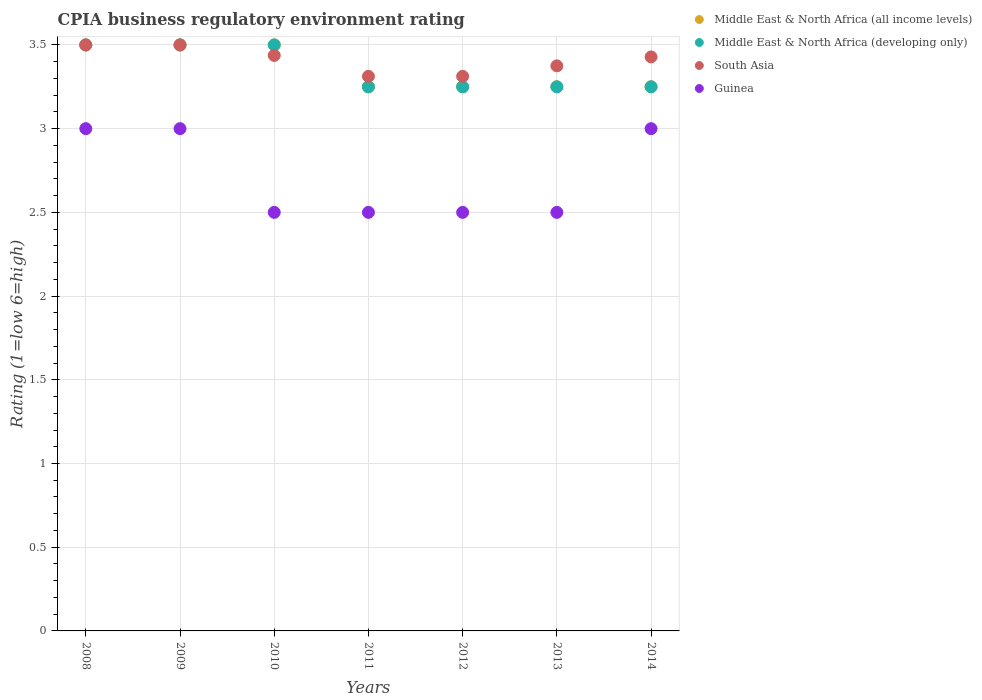How many different coloured dotlines are there?
Your answer should be compact. 4. What is the CPIA rating in Guinea in 2010?
Your answer should be compact. 2.5. Across all years, what is the minimum CPIA rating in South Asia?
Offer a very short reply. 3.31. In which year was the CPIA rating in Middle East & North Africa (all income levels) maximum?
Ensure brevity in your answer.  2008. In which year was the CPIA rating in Guinea minimum?
Offer a very short reply. 2010. What is the total CPIA rating in Middle East & North Africa (developing only) in the graph?
Your answer should be very brief. 23.5. What is the difference between the CPIA rating in Guinea in 2010 and that in 2014?
Your response must be concise. -0.5. What is the average CPIA rating in Guinea per year?
Your response must be concise. 2.71. Is the CPIA rating in Middle East & North Africa (developing only) in 2011 less than that in 2012?
Provide a short and direct response. No. Is the difference between the CPIA rating in Middle East & North Africa (developing only) in 2008 and 2009 greater than the difference between the CPIA rating in South Asia in 2008 and 2009?
Provide a succinct answer. No. What is the difference between the highest and the lowest CPIA rating in South Asia?
Your answer should be compact. 0.19. Is the CPIA rating in South Asia strictly greater than the CPIA rating in Middle East & North Africa (all income levels) over the years?
Ensure brevity in your answer.  No. Is the CPIA rating in Middle East & North Africa (all income levels) strictly less than the CPIA rating in Middle East & North Africa (developing only) over the years?
Ensure brevity in your answer.  No. How many years are there in the graph?
Provide a succinct answer. 7. What is the difference between two consecutive major ticks on the Y-axis?
Make the answer very short. 0.5. Are the values on the major ticks of Y-axis written in scientific E-notation?
Offer a very short reply. No. Where does the legend appear in the graph?
Provide a succinct answer. Top right. How are the legend labels stacked?
Your response must be concise. Vertical. What is the title of the graph?
Give a very brief answer. CPIA business regulatory environment rating. Does "South Sudan" appear as one of the legend labels in the graph?
Offer a very short reply. No. What is the label or title of the X-axis?
Your response must be concise. Years. What is the label or title of the Y-axis?
Ensure brevity in your answer.  Rating (1=low 6=high). What is the Rating (1=low 6=high) of Middle East & North Africa (all income levels) in 2008?
Offer a terse response. 3.5. What is the Rating (1=low 6=high) of Guinea in 2008?
Offer a very short reply. 3. What is the Rating (1=low 6=high) in Guinea in 2009?
Provide a succinct answer. 3. What is the Rating (1=low 6=high) in Middle East & North Africa (developing only) in 2010?
Keep it short and to the point. 3.5. What is the Rating (1=low 6=high) of South Asia in 2010?
Ensure brevity in your answer.  3.44. What is the Rating (1=low 6=high) of Middle East & North Africa (developing only) in 2011?
Provide a short and direct response. 3.25. What is the Rating (1=low 6=high) in South Asia in 2011?
Make the answer very short. 3.31. What is the Rating (1=low 6=high) of Guinea in 2011?
Offer a terse response. 2.5. What is the Rating (1=low 6=high) of Middle East & North Africa (developing only) in 2012?
Keep it short and to the point. 3.25. What is the Rating (1=low 6=high) of South Asia in 2012?
Offer a very short reply. 3.31. What is the Rating (1=low 6=high) of Guinea in 2012?
Provide a short and direct response. 2.5. What is the Rating (1=low 6=high) of Middle East & North Africa (all income levels) in 2013?
Your answer should be very brief. 3.25. What is the Rating (1=low 6=high) of Middle East & North Africa (developing only) in 2013?
Your answer should be compact. 3.25. What is the Rating (1=low 6=high) of South Asia in 2013?
Your response must be concise. 3.38. What is the Rating (1=low 6=high) in Guinea in 2013?
Make the answer very short. 2.5. What is the Rating (1=low 6=high) of South Asia in 2014?
Your response must be concise. 3.43. What is the Rating (1=low 6=high) of Guinea in 2014?
Give a very brief answer. 3. Across all years, what is the maximum Rating (1=low 6=high) of Middle East & North Africa (all income levels)?
Ensure brevity in your answer.  3.5. Across all years, what is the maximum Rating (1=low 6=high) in Middle East & North Africa (developing only)?
Ensure brevity in your answer.  3.5. Across all years, what is the maximum Rating (1=low 6=high) in Guinea?
Make the answer very short. 3. Across all years, what is the minimum Rating (1=low 6=high) of Middle East & North Africa (developing only)?
Offer a very short reply. 3.25. Across all years, what is the minimum Rating (1=low 6=high) in South Asia?
Offer a very short reply. 3.31. What is the total Rating (1=low 6=high) of Middle East & North Africa (all income levels) in the graph?
Your answer should be compact. 23.5. What is the total Rating (1=low 6=high) in South Asia in the graph?
Give a very brief answer. 23.87. What is the difference between the Rating (1=low 6=high) of Middle East & North Africa (developing only) in 2008 and that in 2009?
Your answer should be very brief. 0. What is the difference between the Rating (1=low 6=high) of Guinea in 2008 and that in 2009?
Your answer should be compact. 0. What is the difference between the Rating (1=low 6=high) in Middle East & North Africa (all income levels) in 2008 and that in 2010?
Offer a terse response. 0. What is the difference between the Rating (1=low 6=high) in South Asia in 2008 and that in 2010?
Your answer should be very brief. 0.06. What is the difference between the Rating (1=low 6=high) in Guinea in 2008 and that in 2010?
Your response must be concise. 0.5. What is the difference between the Rating (1=low 6=high) in Middle East & North Africa (all income levels) in 2008 and that in 2011?
Ensure brevity in your answer.  0.25. What is the difference between the Rating (1=low 6=high) in South Asia in 2008 and that in 2011?
Ensure brevity in your answer.  0.19. What is the difference between the Rating (1=low 6=high) of Middle East & North Africa (developing only) in 2008 and that in 2012?
Ensure brevity in your answer.  0.25. What is the difference between the Rating (1=low 6=high) of South Asia in 2008 and that in 2012?
Ensure brevity in your answer.  0.19. What is the difference between the Rating (1=low 6=high) in Middle East & North Africa (all income levels) in 2008 and that in 2013?
Your answer should be very brief. 0.25. What is the difference between the Rating (1=low 6=high) of Middle East & North Africa (developing only) in 2008 and that in 2013?
Provide a short and direct response. 0.25. What is the difference between the Rating (1=low 6=high) in South Asia in 2008 and that in 2014?
Your answer should be very brief. 0.07. What is the difference between the Rating (1=low 6=high) in Guinea in 2008 and that in 2014?
Keep it short and to the point. 0. What is the difference between the Rating (1=low 6=high) in Middle East & North Africa (developing only) in 2009 and that in 2010?
Give a very brief answer. 0. What is the difference between the Rating (1=low 6=high) of South Asia in 2009 and that in 2010?
Your answer should be very brief. 0.06. What is the difference between the Rating (1=low 6=high) in South Asia in 2009 and that in 2011?
Give a very brief answer. 0.19. What is the difference between the Rating (1=low 6=high) of Guinea in 2009 and that in 2011?
Make the answer very short. 0.5. What is the difference between the Rating (1=low 6=high) in South Asia in 2009 and that in 2012?
Ensure brevity in your answer.  0.19. What is the difference between the Rating (1=low 6=high) in Guinea in 2009 and that in 2012?
Offer a terse response. 0.5. What is the difference between the Rating (1=low 6=high) in Middle East & North Africa (all income levels) in 2009 and that in 2013?
Offer a terse response. 0.25. What is the difference between the Rating (1=low 6=high) in Middle East & North Africa (developing only) in 2009 and that in 2013?
Your answer should be very brief. 0.25. What is the difference between the Rating (1=low 6=high) in South Asia in 2009 and that in 2013?
Provide a short and direct response. 0.12. What is the difference between the Rating (1=low 6=high) of Middle East & North Africa (developing only) in 2009 and that in 2014?
Offer a terse response. 0.25. What is the difference between the Rating (1=low 6=high) of South Asia in 2009 and that in 2014?
Offer a very short reply. 0.07. What is the difference between the Rating (1=low 6=high) of Guinea in 2010 and that in 2011?
Provide a succinct answer. 0. What is the difference between the Rating (1=low 6=high) of Middle East & North Africa (all income levels) in 2010 and that in 2012?
Your response must be concise. 0.25. What is the difference between the Rating (1=low 6=high) in South Asia in 2010 and that in 2012?
Your answer should be very brief. 0.12. What is the difference between the Rating (1=low 6=high) of Guinea in 2010 and that in 2012?
Keep it short and to the point. 0. What is the difference between the Rating (1=low 6=high) in Middle East & North Africa (all income levels) in 2010 and that in 2013?
Your response must be concise. 0.25. What is the difference between the Rating (1=low 6=high) of South Asia in 2010 and that in 2013?
Your response must be concise. 0.06. What is the difference between the Rating (1=low 6=high) of Middle East & North Africa (all income levels) in 2010 and that in 2014?
Your response must be concise. 0.25. What is the difference between the Rating (1=low 6=high) of Middle East & North Africa (developing only) in 2010 and that in 2014?
Your response must be concise. 0.25. What is the difference between the Rating (1=low 6=high) of South Asia in 2010 and that in 2014?
Provide a short and direct response. 0.01. What is the difference between the Rating (1=low 6=high) in Guinea in 2011 and that in 2012?
Offer a terse response. 0. What is the difference between the Rating (1=low 6=high) of Middle East & North Africa (developing only) in 2011 and that in 2013?
Offer a very short reply. 0. What is the difference between the Rating (1=low 6=high) in South Asia in 2011 and that in 2013?
Provide a succinct answer. -0.06. What is the difference between the Rating (1=low 6=high) of Guinea in 2011 and that in 2013?
Your answer should be compact. 0. What is the difference between the Rating (1=low 6=high) of South Asia in 2011 and that in 2014?
Keep it short and to the point. -0.12. What is the difference between the Rating (1=low 6=high) in Middle East & North Africa (developing only) in 2012 and that in 2013?
Provide a short and direct response. 0. What is the difference between the Rating (1=low 6=high) of South Asia in 2012 and that in 2013?
Keep it short and to the point. -0.06. What is the difference between the Rating (1=low 6=high) of Guinea in 2012 and that in 2013?
Offer a very short reply. 0. What is the difference between the Rating (1=low 6=high) in Middle East & North Africa (developing only) in 2012 and that in 2014?
Offer a very short reply. 0. What is the difference between the Rating (1=low 6=high) of South Asia in 2012 and that in 2014?
Provide a succinct answer. -0.12. What is the difference between the Rating (1=low 6=high) in Middle East & North Africa (all income levels) in 2013 and that in 2014?
Provide a succinct answer. 0. What is the difference between the Rating (1=low 6=high) in South Asia in 2013 and that in 2014?
Your answer should be compact. -0.05. What is the difference between the Rating (1=low 6=high) in Guinea in 2013 and that in 2014?
Provide a succinct answer. -0.5. What is the difference between the Rating (1=low 6=high) of Middle East & North Africa (all income levels) in 2008 and the Rating (1=low 6=high) of Middle East & North Africa (developing only) in 2009?
Your answer should be compact. 0. What is the difference between the Rating (1=low 6=high) of Middle East & North Africa (all income levels) in 2008 and the Rating (1=low 6=high) of South Asia in 2009?
Keep it short and to the point. 0. What is the difference between the Rating (1=low 6=high) in Middle East & North Africa (all income levels) in 2008 and the Rating (1=low 6=high) in Guinea in 2009?
Offer a very short reply. 0.5. What is the difference between the Rating (1=low 6=high) of Middle East & North Africa (developing only) in 2008 and the Rating (1=low 6=high) of South Asia in 2009?
Give a very brief answer. 0. What is the difference between the Rating (1=low 6=high) of Middle East & North Africa (developing only) in 2008 and the Rating (1=low 6=high) of Guinea in 2009?
Provide a succinct answer. 0.5. What is the difference between the Rating (1=low 6=high) of Middle East & North Africa (all income levels) in 2008 and the Rating (1=low 6=high) of Middle East & North Africa (developing only) in 2010?
Your answer should be compact. 0. What is the difference between the Rating (1=low 6=high) in Middle East & North Africa (all income levels) in 2008 and the Rating (1=low 6=high) in South Asia in 2010?
Offer a very short reply. 0.06. What is the difference between the Rating (1=low 6=high) of Middle East & North Africa (all income levels) in 2008 and the Rating (1=low 6=high) of Guinea in 2010?
Ensure brevity in your answer.  1. What is the difference between the Rating (1=low 6=high) of Middle East & North Africa (developing only) in 2008 and the Rating (1=low 6=high) of South Asia in 2010?
Provide a short and direct response. 0.06. What is the difference between the Rating (1=low 6=high) in South Asia in 2008 and the Rating (1=low 6=high) in Guinea in 2010?
Ensure brevity in your answer.  1. What is the difference between the Rating (1=low 6=high) of Middle East & North Africa (all income levels) in 2008 and the Rating (1=low 6=high) of Middle East & North Africa (developing only) in 2011?
Your answer should be very brief. 0.25. What is the difference between the Rating (1=low 6=high) in Middle East & North Africa (all income levels) in 2008 and the Rating (1=low 6=high) in South Asia in 2011?
Give a very brief answer. 0.19. What is the difference between the Rating (1=low 6=high) of Middle East & North Africa (developing only) in 2008 and the Rating (1=low 6=high) of South Asia in 2011?
Provide a short and direct response. 0.19. What is the difference between the Rating (1=low 6=high) of Middle East & North Africa (all income levels) in 2008 and the Rating (1=low 6=high) of Middle East & North Africa (developing only) in 2012?
Give a very brief answer. 0.25. What is the difference between the Rating (1=low 6=high) in Middle East & North Africa (all income levels) in 2008 and the Rating (1=low 6=high) in South Asia in 2012?
Give a very brief answer. 0.19. What is the difference between the Rating (1=low 6=high) of Middle East & North Africa (all income levels) in 2008 and the Rating (1=low 6=high) of Guinea in 2012?
Your answer should be compact. 1. What is the difference between the Rating (1=low 6=high) of Middle East & North Africa (developing only) in 2008 and the Rating (1=low 6=high) of South Asia in 2012?
Offer a terse response. 0.19. What is the difference between the Rating (1=low 6=high) in Middle East & North Africa (developing only) in 2008 and the Rating (1=low 6=high) in Guinea in 2012?
Offer a very short reply. 1. What is the difference between the Rating (1=low 6=high) of South Asia in 2008 and the Rating (1=low 6=high) of Guinea in 2012?
Provide a succinct answer. 1. What is the difference between the Rating (1=low 6=high) in Middle East & North Africa (all income levels) in 2008 and the Rating (1=low 6=high) in South Asia in 2013?
Give a very brief answer. 0.12. What is the difference between the Rating (1=low 6=high) of Middle East & North Africa (developing only) in 2008 and the Rating (1=low 6=high) of Guinea in 2013?
Give a very brief answer. 1. What is the difference between the Rating (1=low 6=high) in South Asia in 2008 and the Rating (1=low 6=high) in Guinea in 2013?
Offer a very short reply. 1. What is the difference between the Rating (1=low 6=high) of Middle East & North Africa (all income levels) in 2008 and the Rating (1=low 6=high) of Middle East & North Africa (developing only) in 2014?
Your answer should be very brief. 0.25. What is the difference between the Rating (1=low 6=high) in Middle East & North Africa (all income levels) in 2008 and the Rating (1=low 6=high) in South Asia in 2014?
Offer a terse response. 0.07. What is the difference between the Rating (1=low 6=high) in Middle East & North Africa (developing only) in 2008 and the Rating (1=low 6=high) in South Asia in 2014?
Give a very brief answer. 0.07. What is the difference between the Rating (1=low 6=high) of Middle East & North Africa (developing only) in 2008 and the Rating (1=low 6=high) of Guinea in 2014?
Your response must be concise. 0.5. What is the difference between the Rating (1=low 6=high) in South Asia in 2008 and the Rating (1=low 6=high) in Guinea in 2014?
Offer a very short reply. 0.5. What is the difference between the Rating (1=low 6=high) in Middle East & North Africa (all income levels) in 2009 and the Rating (1=low 6=high) in South Asia in 2010?
Provide a short and direct response. 0.06. What is the difference between the Rating (1=low 6=high) in Middle East & North Africa (all income levels) in 2009 and the Rating (1=low 6=high) in Guinea in 2010?
Provide a short and direct response. 1. What is the difference between the Rating (1=low 6=high) of Middle East & North Africa (developing only) in 2009 and the Rating (1=low 6=high) of South Asia in 2010?
Your answer should be compact. 0.06. What is the difference between the Rating (1=low 6=high) in Middle East & North Africa (developing only) in 2009 and the Rating (1=low 6=high) in Guinea in 2010?
Offer a terse response. 1. What is the difference between the Rating (1=low 6=high) in Middle East & North Africa (all income levels) in 2009 and the Rating (1=low 6=high) in Middle East & North Africa (developing only) in 2011?
Provide a succinct answer. 0.25. What is the difference between the Rating (1=low 6=high) of Middle East & North Africa (all income levels) in 2009 and the Rating (1=low 6=high) of South Asia in 2011?
Offer a very short reply. 0.19. What is the difference between the Rating (1=low 6=high) of Middle East & North Africa (all income levels) in 2009 and the Rating (1=low 6=high) of Guinea in 2011?
Your response must be concise. 1. What is the difference between the Rating (1=low 6=high) of Middle East & North Africa (developing only) in 2009 and the Rating (1=low 6=high) of South Asia in 2011?
Your answer should be very brief. 0.19. What is the difference between the Rating (1=low 6=high) of South Asia in 2009 and the Rating (1=low 6=high) of Guinea in 2011?
Keep it short and to the point. 1. What is the difference between the Rating (1=low 6=high) of Middle East & North Africa (all income levels) in 2009 and the Rating (1=low 6=high) of South Asia in 2012?
Your response must be concise. 0.19. What is the difference between the Rating (1=low 6=high) in Middle East & North Africa (developing only) in 2009 and the Rating (1=low 6=high) in South Asia in 2012?
Offer a very short reply. 0.19. What is the difference between the Rating (1=low 6=high) in Middle East & North Africa (developing only) in 2009 and the Rating (1=low 6=high) in Guinea in 2012?
Make the answer very short. 1. What is the difference between the Rating (1=low 6=high) of South Asia in 2009 and the Rating (1=low 6=high) of Guinea in 2012?
Your answer should be very brief. 1. What is the difference between the Rating (1=low 6=high) in Middle East & North Africa (all income levels) in 2009 and the Rating (1=low 6=high) in Middle East & North Africa (developing only) in 2013?
Offer a terse response. 0.25. What is the difference between the Rating (1=low 6=high) of Middle East & North Africa (all income levels) in 2009 and the Rating (1=low 6=high) of Guinea in 2013?
Keep it short and to the point. 1. What is the difference between the Rating (1=low 6=high) of Middle East & North Africa (developing only) in 2009 and the Rating (1=low 6=high) of Guinea in 2013?
Keep it short and to the point. 1. What is the difference between the Rating (1=low 6=high) of Middle East & North Africa (all income levels) in 2009 and the Rating (1=low 6=high) of South Asia in 2014?
Your answer should be very brief. 0.07. What is the difference between the Rating (1=low 6=high) in Middle East & North Africa (all income levels) in 2009 and the Rating (1=low 6=high) in Guinea in 2014?
Keep it short and to the point. 0.5. What is the difference between the Rating (1=low 6=high) of Middle East & North Africa (developing only) in 2009 and the Rating (1=low 6=high) of South Asia in 2014?
Provide a succinct answer. 0.07. What is the difference between the Rating (1=low 6=high) of South Asia in 2009 and the Rating (1=low 6=high) of Guinea in 2014?
Offer a very short reply. 0.5. What is the difference between the Rating (1=low 6=high) of Middle East & North Africa (all income levels) in 2010 and the Rating (1=low 6=high) of South Asia in 2011?
Your response must be concise. 0.19. What is the difference between the Rating (1=low 6=high) of Middle East & North Africa (developing only) in 2010 and the Rating (1=low 6=high) of South Asia in 2011?
Give a very brief answer. 0.19. What is the difference between the Rating (1=low 6=high) in Middle East & North Africa (developing only) in 2010 and the Rating (1=low 6=high) in Guinea in 2011?
Keep it short and to the point. 1. What is the difference between the Rating (1=low 6=high) in Middle East & North Africa (all income levels) in 2010 and the Rating (1=low 6=high) in South Asia in 2012?
Keep it short and to the point. 0.19. What is the difference between the Rating (1=low 6=high) in Middle East & North Africa (all income levels) in 2010 and the Rating (1=low 6=high) in Guinea in 2012?
Provide a succinct answer. 1. What is the difference between the Rating (1=low 6=high) of Middle East & North Africa (developing only) in 2010 and the Rating (1=low 6=high) of South Asia in 2012?
Offer a very short reply. 0.19. What is the difference between the Rating (1=low 6=high) of Middle East & North Africa (all income levels) in 2010 and the Rating (1=low 6=high) of Middle East & North Africa (developing only) in 2013?
Ensure brevity in your answer.  0.25. What is the difference between the Rating (1=low 6=high) of Middle East & North Africa (all income levels) in 2010 and the Rating (1=low 6=high) of Guinea in 2013?
Give a very brief answer. 1. What is the difference between the Rating (1=low 6=high) of Middle East & North Africa (developing only) in 2010 and the Rating (1=low 6=high) of South Asia in 2013?
Your response must be concise. 0.12. What is the difference between the Rating (1=low 6=high) in Middle East & North Africa (developing only) in 2010 and the Rating (1=low 6=high) in Guinea in 2013?
Give a very brief answer. 1. What is the difference between the Rating (1=low 6=high) of Middle East & North Africa (all income levels) in 2010 and the Rating (1=low 6=high) of Middle East & North Africa (developing only) in 2014?
Provide a short and direct response. 0.25. What is the difference between the Rating (1=low 6=high) of Middle East & North Africa (all income levels) in 2010 and the Rating (1=low 6=high) of South Asia in 2014?
Provide a succinct answer. 0.07. What is the difference between the Rating (1=low 6=high) of Middle East & North Africa (developing only) in 2010 and the Rating (1=low 6=high) of South Asia in 2014?
Your response must be concise. 0.07. What is the difference between the Rating (1=low 6=high) in Middle East & North Africa (developing only) in 2010 and the Rating (1=low 6=high) in Guinea in 2014?
Your answer should be compact. 0.5. What is the difference between the Rating (1=low 6=high) in South Asia in 2010 and the Rating (1=low 6=high) in Guinea in 2014?
Offer a very short reply. 0.44. What is the difference between the Rating (1=low 6=high) of Middle East & North Africa (all income levels) in 2011 and the Rating (1=low 6=high) of South Asia in 2012?
Ensure brevity in your answer.  -0.06. What is the difference between the Rating (1=low 6=high) of Middle East & North Africa (developing only) in 2011 and the Rating (1=low 6=high) of South Asia in 2012?
Your answer should be compact. -0.06. What is the difference between the Rating (1=low 6=high) in Middle East & North Africa (developing only) in 2011 and the Rating (1=low 6=high) in Guinea in 2012?
Your response must be concise. 0.75. What is the difference between the Rating (1=low 6=high) in South Asia in 2011 and the Rating (1=low 6=high) in Guinea in 2012?
Offer a very short reply. 0.81. What is the difference between the Rating (1=low 6=high) in Middle East & North Africa (all income levels) in 2011 and the Rating (1=low 6=high) in South Asia in 2013?
Give a very brief answer. -0.12. What is the difference between the Rating (1=low 6=high) of Middle East & North Africa (all income levels) in 2011 and the Rating (1=low 6=high) of Guinea in 2013?
Your answer should be very brief. 0.75. What is the difference between the Rating (1=low 6=high) of Middle East & North Africa (developing only) in 2011 and the Rating (1=low 6=high) of South Asia in 2013?
Give a very brief answer. -0.12. What is the difference between the Rating (1=low 6=high) of Middle East & North Africa (developing only) in 2011 and the Rating (1=low 6=high) of Guinea in 2013?
Ensure brevity in your answer.  0.75. What is the difference between the Rating (1=low 6=high) in South Asia in 2011 and the Rating (1=low 6=high) in Guinea in 2013?
Give a very brief answer. 0.81. What is the difference between the Rating (1=low 6=high) in Middle East & North Africa (all income levels) in 2011 and the Rating (1=low 6=high) in South Asia in 2014?
Provide a short and direct response. -0.18. What is the difference between the Rating (1=low 6=high) of Middle East & North Africa (all income levels) in 2011 and the Rating (1=low 6=high) of Guinea in 2014?
Give a very brief answer. 0.25. What is the difference between the Rating (1=low 6=high) in Middle East & North Africa (developing only) in 2011 and the Rating (1=low 6=high) in South Asia in 2014?
Keep it short and to the point. -0.18. What is the difference between the Rating (1=low 6=high) in Middle East & North Africa (developing only) in 2011 and the Rating (1=low 6=high) in Guinea in 2014?
Ensure brevity in your answer.  0.25. What is the difference between the Rating (1=low 6=high) in South Asia in 2011 and the Rating (1=low 6=high) in Guinea in 2014?
Give a very brief answer. 0.31. What is the difference between the Rating (1=low 6=high) of Middle East & North Africa (all income levels) in 2012 and the Rating (1=low 6=high) of South Asia in 2013?
Your answer should be compact. -0.12. What is the difference between the Rating (1=low 6=high) of Middle East & North Africa (all income levels) in 2012 and the Rating (1=low 6=high) of Guinea in 2013?
Your answer should be very brief. 0.75. What is the difference between the Rating (1=low 6=high) of Middle East & North Africa (developing only) in 2012 and the Rating (1=low 6=high) of South Asia in 2013?
Make the answer very short. -0.12. What is the difference between the Rating (1=low 6=high) of Middle East & North Africa (developing only) in 2012 and the Rating (1=low 6=high) of Guinea in 2013?
Provide a short and direct response. 0.75. What is the difference between the Rating (1=low 6=high) of South Asia in 2012 and the Rating (1=low 6=high) of Guinea in 2013?
Keep it short and to the point. 0.81. What is the difference between the Rating (1=low 6=high) in Middle East & North Africa (all income levels) in 2012 and the Rating (1=low 6=high) in Middle East & North Africa (developing only) in 2014?
Your answer should be compact. 0. What is the difference between the Rating (1=low 6=high) in Middle East & North Africa (all income levels) in 2012 and the Rating (1=low 6=high) in South Asia in 2014?
Make the answer very short. -0.18. What is the difference between the Rating (1=low 6=high) of Middle East & North Africa (all income levels) in 2012 and the Rating (1=low 6=high) of Guinea in 2014?
Provide a succinct answer. 0.25. What is the difference between the Rating (1=low 6=high) of Middle East & North Africa (developing only) in 2012 and the Rating (1=low 6=high) of South Asia in 2014?
Ensure brevity in your answer.  -0.18. What is the difference between the Rating (1=low 6=high) in Middle East & North Africa (developing only) in 2012 and the Rating (1=low 6=high) in Guinea in 2014?
Keep it short and to the point. 0.25. What is the difference between the Rating (1=low 6=high) of South Asia in 2012 and the Rating (1=low 6=high) of Guinea in 2014?
Give a very brief answer. 0.31. What is the difference between the Rating (1=low 6=high) in Middle East & North Africa (all income levels) in 2013 and the Rating (1=low 6=high) in South Asia in 2014?
Offer a very short reply. -0.18. What is the difference between the Rating (1=low 6=high) of Middle East & North Africa (developing only) in 2013 and the Rating (1=low 6=high) of South Asia in 2014?
Offer a terse response. -0.18. What is the difference between the Rating (1=low 6=high) of Middle East & North Africa (developing only) in 2013 and the Rating (1=low 6=high) of Guinea in 2014?
Provide a short and direct response. 0.25. What is the difference between the Rating (1=low 6=high) of South Asia in 2013 and the Rating (1=low 6=high) of Guinea in 2014?
Make the answer very short. 0.38. What is the average Rating (1=low 6=high) of Middle East & North Africa (all income levels) per year?
Offer a very short reply. 3.36. What is the average Rating (1=low 6=high) in Middle East & North Africa (developing only) per year?
Give a very brief answer. 3.36. What is the average Rating (1=low 6=high) in South Asia per year?
Provide a short and direct response. 3.41. What is the average Rating (1=low 6=high) of Guinea per year?
Make the answer very short. 2.71. In the year 2008, what is the difference between the Rating (1=low 6=high) of Middle East & North Africa (developing only) and Rating (1=low 6=high) of South Asia?
Provide a succinct answer. 0. In the year 2008, what is the difference between the Rating (1=low 6=high) of Middle East & North Africa (developing only) and Rating (1=low 6=high) of Guinea?
Provide a short and direct response. 0.5. In the year 2008, what is the difference between the Rating (1=low 6=high) of South Asia and Rating (1=low 6=high) of Guinea?
Your response must be concise. 0.5. In the year 2009, what is the difference between the Rating (1=low 6=high) of Middle East & North Africa (all income levels) and Rating (1=low 6=high) of Middle East & North Africa (developing only)?
Keep it short and to the point. 0. In the year 2009, what is the difference between the Rating (1=low 6=high) in South Asia and Rating (1=low 6=high) in Guinea?
Provide a succinct answer. 0.5. In the year 2010, what is the difference between the Rating (1=low 6=high) in Middle East & North Africa (all income levels) and Rating (1=low 6=high) in South Asia?
Ensure brevity in your answer.  0.06. In the year 2010, what is the difference between the Rating (1=low 6=high) in Middle East & North Africa (all income levels) and Rating (1=low 6=high) in Guinea?
Keep it short and to the point. 1. In the year 2010, what is the difference between the Rating (1=low 6=high) of Middle East & North Africa (developing only) and Rating (1=low 6=high) of South Asia?
Offer a very short reply. 0.06. In the year 2010, what is the difference between the Rating (1=low 6=high) of South Asia and Rating (1=low 6=high) of Guinea?
Provide a short and direct response. 0.94. In the year 2011, what is the difference between the Rating (1=low 6=high) of Middle East & North Africa (all income levels) and Rating (1=low 6=high) of South Asia?
Ensure brevity in your answer.  -0.06. In the year 2011, what is the difference between the Rating (1=low 6=high) of Middle East & North Africa (all income levels) and Rating (1=low 6=high) of Guinea?
Ensure brevity in your answer.  0.75. In the year 2011, what is the difference between the Rating (1=low 6=high) in Middle East & North Africa (developing only) and Rating (1=low 6=high) in South Asia?
Provide a succinct answer. -0.06. In the year 2011, what is the difference between the Rating (1=low 6=high) of South Asia and Rating (1=low 6=high) of Guinea?
Provide a succinct answer. 0.81. In the year 2012, what is the difference between the Rating (1=low 6=high) in Middle East & North Africa (all income levels) and Rating (1=low 6=high) in South Asia?
Provide a short and direct response. -0.06. In the year 2012, what is the difference between the Rating (1=low 6=high) in Middle East & North Africa (developing only) and Rating (1=low 6=high) in South Asia?
Your answer should be compact. -0.06. In the year 2012, what is the difference between the Rating (1=low 6=high) in Middle East & North Africa (developing only) and Rating (1=low 6=high) in Guinea?
Provide a short and direct response. 0.75. In the year 2012, what is the difference between the Rating (1=low 6=high) of South Asia and Rating (1=low 6=high) of Guinea?
Your answer should be compact. 0.81. In the year 2013, what is the difference between the Rating (1=low 6=high) in Middle East & North Africa (all income levels) and Rating (1=low 6=high) in Middle East & North Africa (developing only)?
Offer a terse response. 0. In the year 2013, what is the difference between the Rating (1=low 6=high) of Middle East & North Africa (all income levels) and Rating (1=low 6=high) of South Asia?
Offer a terse response. -0.12. In the year 2013, what is the difference between the Rating (1=low 6=high) of Middle East & North Africa (developing only) and Rating (1=low 6=high) of South Asia?
Provide a succinct answer. -0.12. In the year 2014, what is the difference between the Rating (1=low 6=high) of Middle East & North Africa (all income levels) and Rating (1=low 6=high) of South Asia?
Provide a succinct answer. -0.18. In the year 2014, what is the difference between the Rating (1=low 6=high) of Middle East & North Africa (developing only) and Rating (1=low 6=high) of South Asia?
Provide a succinct answer. -0.18. In the year 2014, what is the difference between the Rating (1=low 6=high) of South Asia and Rating (1=low 6=high) of Guinea?
Your answer should be compact. 0.43. What is the ratio of the Rating (1=low 6=high) of Middle East & North Africa (developing only) in 2008 to that in 2009?
Ensure brevity in your answer.  1. What is the ratio of the Rating (1=low 6=high) in South Asia in 2008 to that in 2010?
Make the answer very short. 1.02. What is the ratio of the Rating (1=low 6=high) in Guinea in 2008 to that in 2010?
Provide a short and direct response. 1.2. What is the ratio of the Rating (1=low 6=high) in Middle East & North Africa (developing only) in 2008 to that in 2011?
Give a very brief answer. 1.08. What is the ratio of the Rating (1=low 6=high) in South Asia in 2008 to that in 2011?
Ensure brevity in your answer.  1.06. What is the ratio of the Rating (1=low 6=high) in Middle East & North Africa (developing only) in 2008 to that in 2012?
Provide a short and direct response. 1.08. What is the ratio of the Rating (1=low 6=high) of South Asia in 2008 to that in 2012?
Ensure brevity in your answer.  1.06. What is the ratio of the Rating (1=low 6=high) in Middle East & North Africa (all income levels) in 2008 to that in 2013?
Provide a succinct answer. 1.08. What is the ratio of the Rating (1=low 6=high) in Middle East & North Africa (developing only) in 2008 to that in 2013?
Your answer should be very brief. 1.08. What is the ratio of the Rating (1=low 6=high) in South Asia in 2008 to that in 2013?
Offer a very short reply. 1.04. What is the ratio of the Rating (1=low 6=high) of Guinea in 2008 to that in 2013?
Give a very brief answer. 1.2. What is the ratio of the Rating (1=low 6=high) in Middle East & North Africa (all income levels) in 2008 to that in 2014?
Ensure brevity in your answer.  1.08. What is the ratio of the Rating (1=low 6=high) of Middle East & North Africa (developing only) in 2008 to that in 2014?
Give a very brief answer. 1.08. What is the ratio of the Rating (1=low 6=high) of South Asia in 2008 to that in 2014?
Offer a terse response. 1.02. What is the ratio of the Rating (1=low 6=high) in South Asia in 2009 to that in 2010?
Offer a very short reply. 1.02. What is the ratio of the Rating (1=low 6=high) of Middle East & North Africa (developing only) in 2009 to that in 2011?
Provide a succinct answer. 1.08. What is the ratio of the Rating (1=low 6=high) in South Asia in 2009 to that in 2011?
Make the answer very short. 1.06. What is the ratio of the Rating (1=low 6=high) of Guinea in 2009 to that in 2011?
Keep it short and to the point. 1.2. What is the ratio of the Rating (1=low 6=high) of South Asia in 2009 to that in 2012?
Your answer should be compact. 1.06. What is the ratio of the Rating (1=low 6=high) of Guinea in 2009 to that in 2013?
Your answer should be compact. 1.2. What is the ratio of the Rating (1=low 6=high) in Middle East & North Africa (all income levels) in 2009 to that in 2014?
Provide a short and direct response. 1.08. What is the ratio of the Rating (1=low 6=high) in Middle East & North Africa (developing only) in 2009 to that in 2014?
Give a very brief answer. 1.08. What is the ratio of the Rating (1=low 6=high) of South Asia in 2009 to that in 2014?
Ensure brevity in your answer.  1.02. What is the ratio of the Rating (1=low 6=high) in Middle East & North Africa (developing only) in 2010 to that in 2011?
Give a very brief answer. 1.08. What is the ratio of the Rating (1=low 6=high) of South Asia in 2010 to that in 2011?
Keep it short and to the point. 1.04. What is the ratio of the Rating (1=low 6=high) in Guinea in 2010 to that in 2011?
Offer a very short reply. 1. What is the ratio of the Rating (1=low 6=high) of Middle East & North Africa (all income levels) in 2010 to that in 2012?
Your answer should be very brief. 1.08. What is the ratio of the Rating (1=low 6=high) in Middle East & North Africa (developing only) in 2010 to that in 2012?
Provide a succinct answer. 1.08. What is the ratio of the Rating (1=low 6=high) in South Asia in 2010 to that in 2012?
Your answer should be compact. 1.04. What is the ratio of the Rating (1=low 6=high) in South Asia in 2010 to that in 2013?
Provide a short and direct response. 1.02. What is the ratio of the Rating (1=low 6=high) of Middle East & North Africa (all income levels) in 2010 to that in 2014?
Your answer should be very brief. 1.08. What is the ratio of the Rating (1=low 6=high) in Middle East & North Africa (developing only) in 2010 to that in 2014?
Your answer should be compact. 1.08. What is the ratio of the Rating (1=low 6=high) in South Asia in 2010 to that in 2014?
Provide a succinct answer. 1. What is the ratio of the Rating (1=low 6=high) of Guinea in 2010 to that in 2014?
Offer a very short reply. 0.83. What is the ratio of the Rating (1=low 6=high) in South Asia in 2011 to that in 2012?
Offer a very short reply. 1. What is the ratio of the Rating (1=low 6=high) in Guinea in 2011 to that in 2012?
Offer a terse response. 1. What is the ratio of the Rating (1=low 6=high) in Middle East & North Africa (all income levels) in 2011 to that in 2013?
Provide a succinct answer. 1. What is the ratio of the Rating (1=low 6=high) of Middle East & North Africa (developing only) in 2011 to that in 2013?
Give a very brief answer. 1. What is the ratio of the Rating (1=low 6=high) in South Asia in 2011 to that in 2013?
Provide a succinct answer. 0.98. What is the ratio of the Rating (1=low 6=high) of South Asia in 2011 to that in 2014?
Provide a succinct answer. 0.97. What is the ratio of the Rating (1=low 6=high) in Guinea in 2011 to that in 2014?
Your response must be concise. 0.83. What is the ratio of the Rating (1=low 6=high) of Middle East & North Africa (developing only) in 2012 to that in 2013?
Provide a short and direct response. 1. What is the ratio of the Rating (1=low 6=high) of South Asia in 2012 to that in 2013?
Give a very brief answer. 0.98. What is the ratio of the Rating (1=low 6=high) in Middle East & North Africa (developing only) in 2012 to that in 2014?
Offer a very short reply. 1. What is the ratio of the Rating (1=low 6=high) in South Asia in 2012 to that in 2014?
Your answer should be very brief. 0.97. What is the ratio of the Rating (1=low 6=high) in Guinea in 2012 to that in 2014?
Ensure brevity in your answer.  0.83. What is the ratio of the Rating (1=low 6=high) in Middle East & North Africa (all income levels) in 2013 to that in 2014?
Make the answer very short. 1. What is the ratio of the Rating (1=low 6=high) of Middle East & North Africa (developing only) in 2013 to that in 2014?
Your response must be concise. 1. What is the ratio of the Rating (1=low 6=high) of South Asia in 2013 to that in 2014?
Give a very brief answer. 0.98. What is the ratio of the Rating (1=low 6=high) in Guinea in 2013 to that in 2014?
Ensure brevity in your answer.  0.83. What is the difference between the highest and the second highest Rating (1=low 6=high) in Middle East & North Africa (all income levels)?
Make the answer very short. 0. What is the difference between the highest and the second highest Rating (1=low 6=high) of South Asia?
Ensure brevity in your answer.  0. What is the difference between the highest and the second highest Rating (1=low 6=high) of Guinea?
Provide a short and direct response. 0. What is the difference between the highest and the lowest Rating (1=low 6=high) of Middle East & North Africa (all income levels)?
Offer a very short reply. 0.25. What is the difference between the highest and the lowest Rating (1=low 6=high) of Middle East & North Africa (developing only)?
Give a very brief answer. 0.25. What is the difference between the highest and the lowest Rating (1=low 6=high) of South Asia?
Keep it short and to the point. 0.19. 